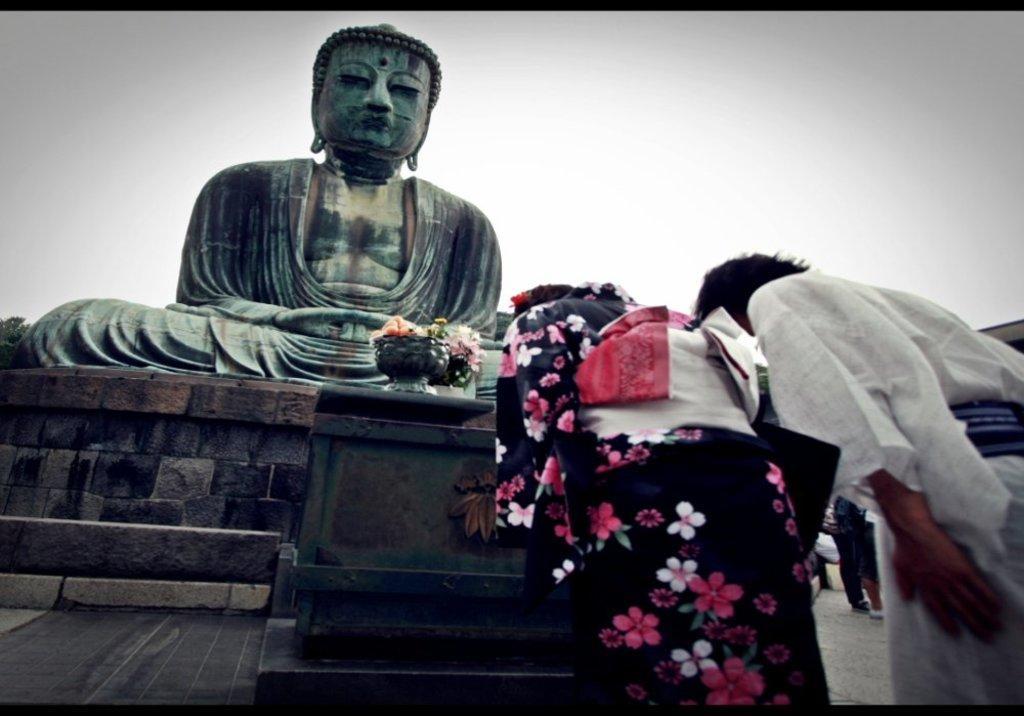Describe this image in one or two sentences. In this picture I can see there is a statue of a person and there are two persons standing at right side. In the backdrop the sky is clear. 